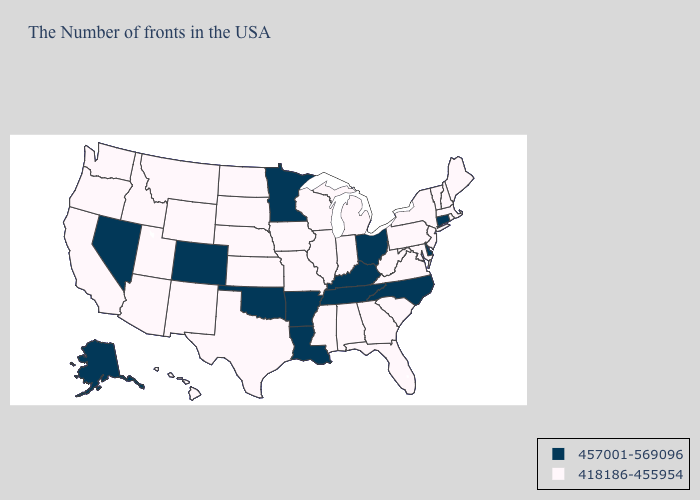What is the lowest value in the South?
Answer briefly. 418186-455954. Is the legend a continuous bar?
Write a very short answer. No. What is the lowest value in the Northeast?
Answer briefly. 418186-455954. Name the states that have a value in the range 457001-569096?
Keep it brief. Connecticut, Delaware, North Carolina, Ohio, Kentucky, Tennessee, Louisiana, Arkansas, Minnesota, Oklahoma, Colorado, Nevada, Alaska. Does Nevada have the highest value in the USA?
Write a very short answer. Yes. Does Wisconsin have a higher value than Connecticut?
Concise answer only. No. What is the lowest value in the USA?
Be succinct. 418186-455954. Does North Carolina have the lowest value in the South?
Keep it brief. No. What is the value of Oklahoma?
Give a very brief answer. 457001-569096. What is the value of Oklahoma?
Answer briefly. 457001-569096. What is the highest value in the Northeast ?
Be succinct. 457001-569096. Name the states that have a value in the range 457001-569096?
Answer briefly. Connecticut, Delaware, North Carolina, Ohio, Kentucky, Tennessee, Louisiana, Arkansas, Minnesota, Oklahoma, Colorado, Nevada, Alaska. Does Connecticut have a lower value than South Carolina?
Give a very brief answer. No. What is the value of Florida?
Quick response, please. 418186-455954. 